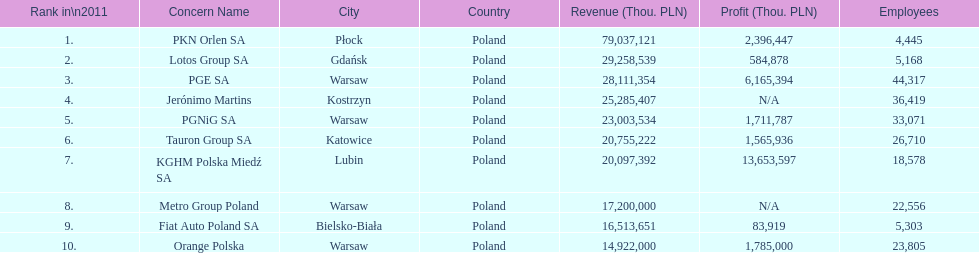Which company had the most employees? PGE SA. 